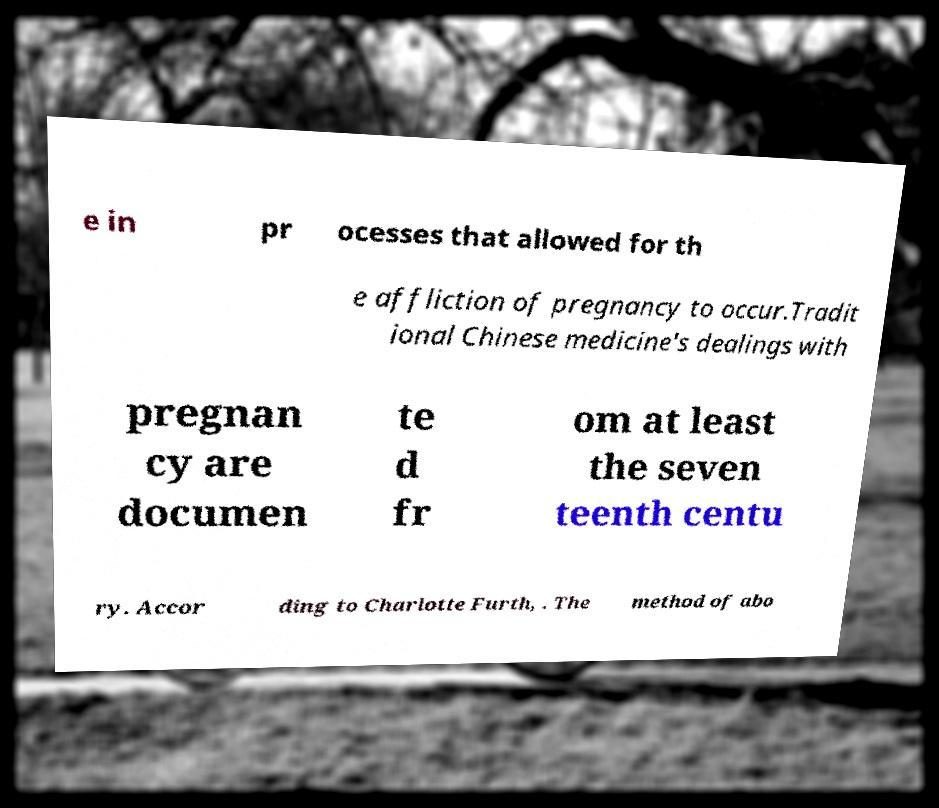There's text embedded in this image that I need extracted. Can you transcribe it verbatim? e in pr ocesses that allowed for th e affliction of pregnancy to occur.Tradit ional Chinese medicine's dealings with pregnan cy are documen te d fr om at least the seven teenth centu ry. Accor ding to Charlotte Furth, . The method of abo 